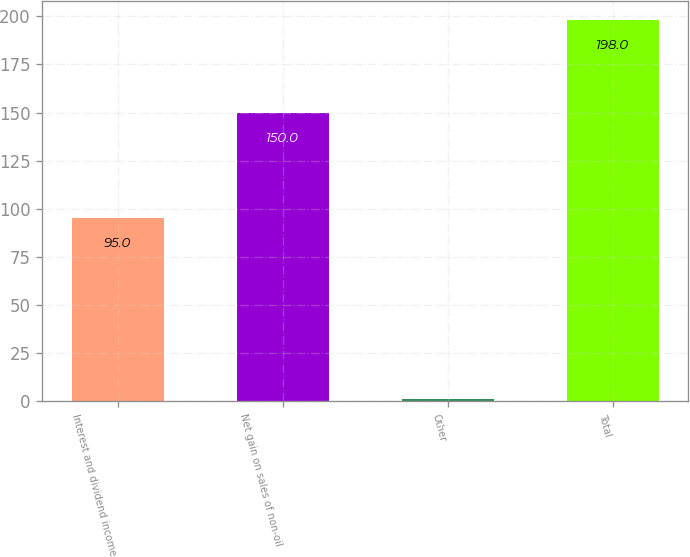Convert chart to OTSL. <chart><loc_0><loc_0><loc_500><loc_500><bar_chart><fcel>Interest and dividend income<fcel>Net gain on sales of non-oil<fcel>Other<fcel>Total<nl><fcel>95<fcel>150<fcel>1<fcel>198<nl></chart> 